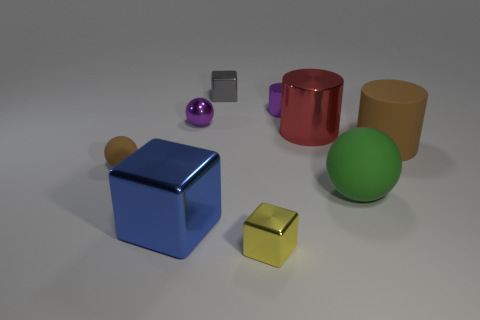Add 1 big brown metal blocks. How many objects exist? 10 Subtract all cylinders. How many objects are left? 6 Add 6 blue metal things. How many blue metal things are left? 7 Add 1 tiny blue rubber blocks. How many tiny blue rubber blocks exist? 1 Subtract 0 cyan balls. How many objects are left? 9 Subtract all large red metallic cylinders. Subtract all big blue shiny objects. How many objects are left? 7 